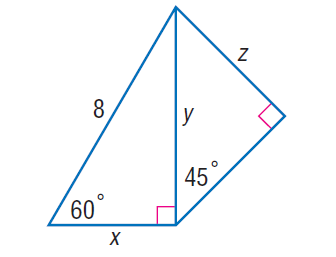Answer the mathemtical geometry problem and directly provide the correct option letter.
Question: Find y.
Choices: A: 4 B: 4 \sqrt { 3 } C: 8 D: 8 \sqrt { 3 } B 